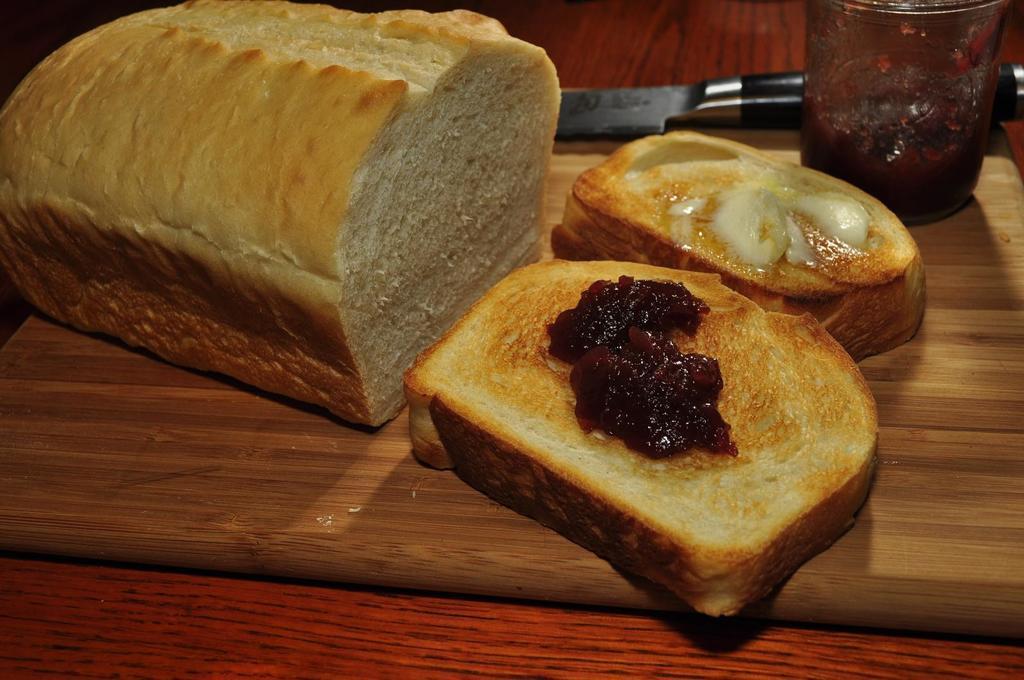Could you give a brief overview of what you see in this image? In this image, we can see a bread pieces and slices with butter and jam, glass and knife. These items are placed on the wooden chopping board. This chopping board is on the wooden surface. 